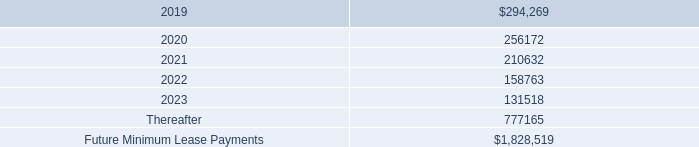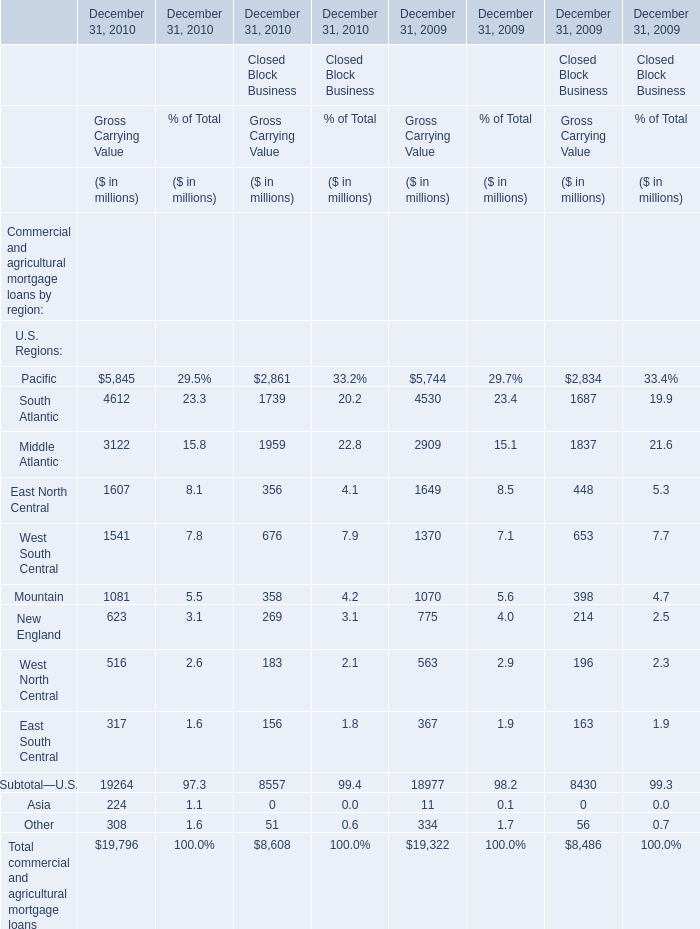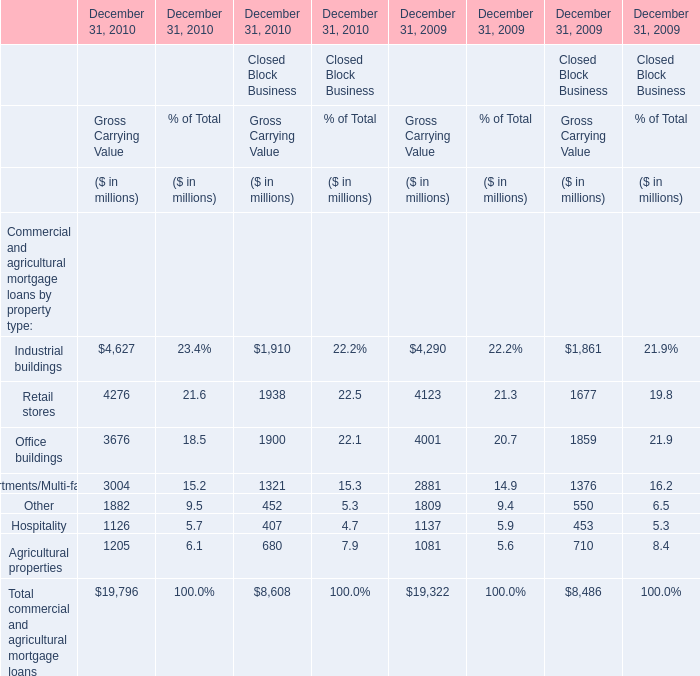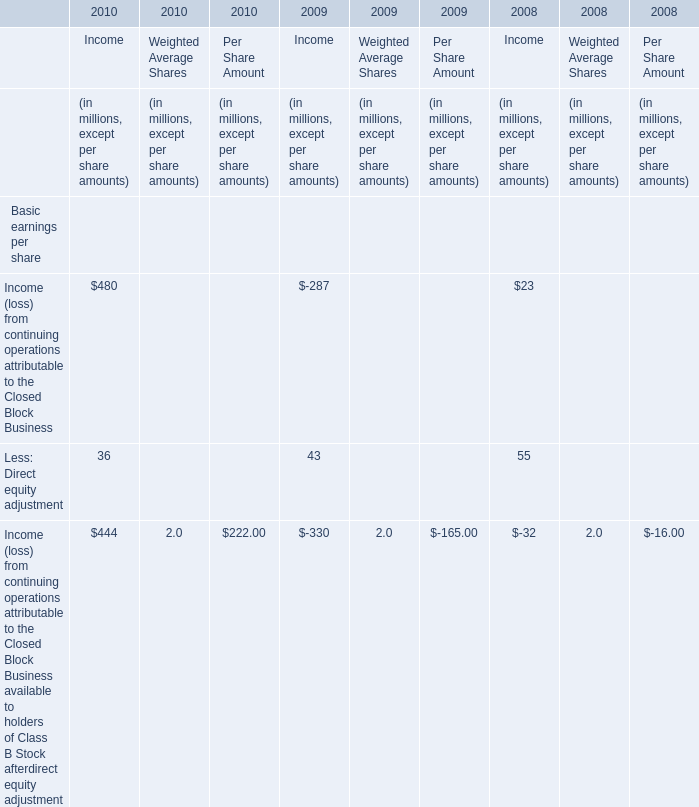In which section the sum of Pacific has the highest value? 
Answer: Gross Carrying Value. 